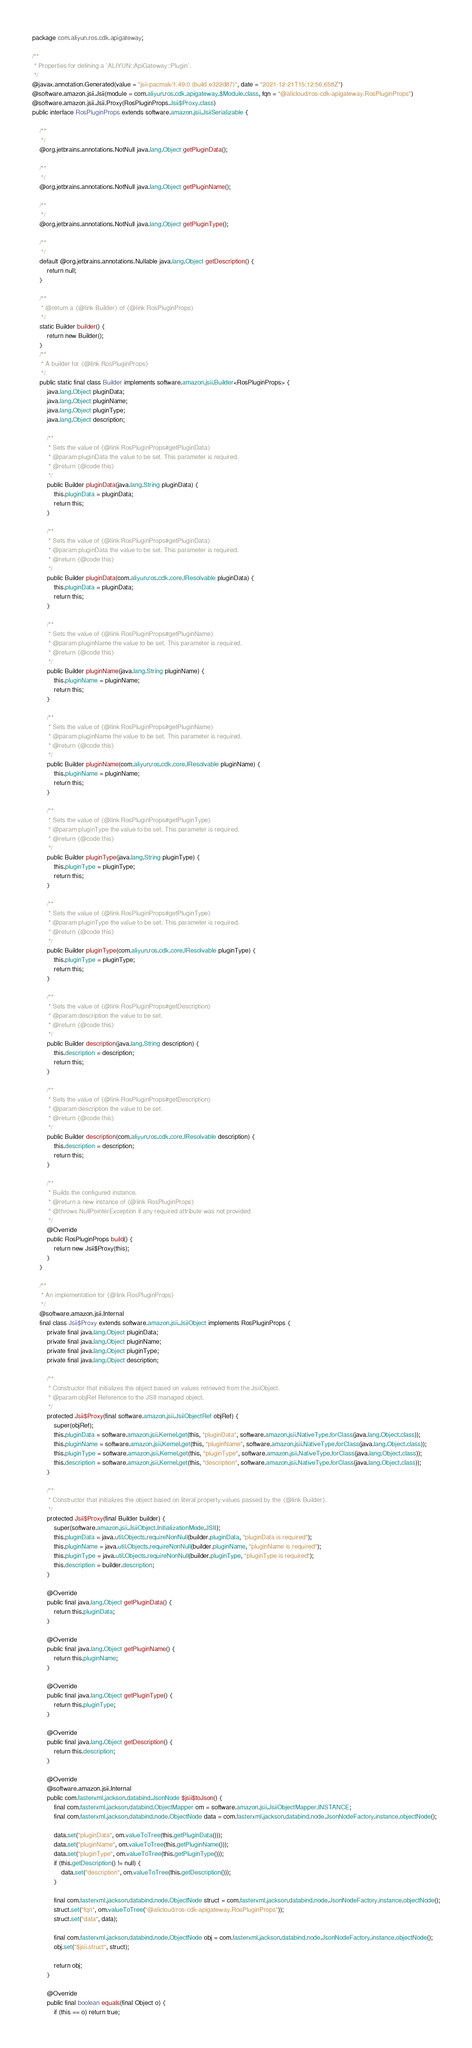<code> <loc_0><loc_0><loc_500><loc_500><_Java_>package com.aliyun.ros.cdk.apigateway;

/**
 * Properties for defining a `ALIYUN::ApiGateway::Plugin`.
 */
@javax.annotation.Generated(value = "jsii-pacmak/1.49.0 (build e322d87)", date = "2021-12-21T15:12:56.658Z")
@software.amazon.jsii.Jsii(module = com.aliyun.ros.cdk.apigateway.$Module.class, fqn = "@alicloud/ros-cdk-apigateway.RosPluginProps")
@software.amazon.jsii.Jsii.Proxy(RosPluginProps.Jsii$Proxy.class)
public interface RosPluginProps extends software.amazon.jsii.JsiiSerializable {

    /**
     */
    @org.jetbrains.annotations.NotNull java.lang.Object getPluginData();

    /**
     */
    @org.jetbrains.annotations.NotNull java.lang.Object getPluginName();

    /**
     */
    @org.jetbrains.annotations.NotNull java.lang.Object getPluginType();

    /**
     */
    default @org.jetbrains.annotations.Nullable java.lang.Object getDescription() {
        return null;
    }

    /**
     * @return a {@link Builder} of {@link RosPluginProps}
     */
    static Builder builder() {
        return new Builder();
    }
    /**
     * A builder for {@link RosPluginProps}
     */
    public static final class Builder implements software.amazon.jsii.Builder<RosPluginProps> {
        java.lang.Object pluginData;
        java.lang.Object pluginName;
        java.lang.Object pluginType;
        java.lang.Object description;

        /**
         * Sets the value of {@link RosPluginProps#getPluginData}
         * @param pluginData the value to be set. This parameter is required.
         * @return {@code this}
         */
        public Builder pluginData(java.lang.String pluginData) {
            this.pluginData = pluginData;
            return this;
        }

        /**
         * Sets the value of {@link RosPluginProps#getPluginData}
         * @param pluginData the value to be set. This parameter is required.
         * @return {@code this}
         */
        public Builder pluginData(com.aliyun.ros.cdk.core.IResolvable pluginData) {
            this.pluginData = pluginData;
            return this;
        }

        /**
         * Sets the value of {@link RosPluginProps#getPluginName}
         * @param pluginName the value to be set. This parameter is required.
         * @return {@code this}
         */
        public Builder pluginName(java.lang.String pluginName) {
            this.pluginName = pluginName;
            return this;
        }

        /**
         * Sets the value of {@link RosPluginProps#getPluginName}
         * @param pluginName the value to be set. This parameter is required.
         * @return {@code this}
         */
        public Builder pluginName(com.aliyun.ros.cdk.core.IResolvable pluginName) {
            this.pluginName = pluginName;
            return this;
        }

        /**
         * Sets the value of {@link RosPluginProps#getPluginType}
         * @param pluginType the value to be set. This parameter is required.
         * @return {@code this}
         */
        public Builder pluginType(java.lang.String pluginType) {
            this.pluginType = pluginType;
            return this;
        }

        /**
         * Sets the value of {@link RosPluginProps#getPluginType}
         * @param pluginType the value to be set. This parameter is required.
         * @return {@code this}
         */
        public Builder pluginType(com.aliyun.ros.cdk.core.IResolvable pluginType) {
            this.pluginType = pluginType;
            return this;
        }

        /**
         * Sets the value of {@link RosPluginProps#getDescription}
         * @param description the value to be set.
         * @return {@code this}
         */
        public Builder description(java.lang.String description) {
            this.description = description;
            return this;
        }

        /**
         * Sets the value of {@link RosPluginProps#getDescription}
         * @param description the value to be set.
         * @return {@code this}
         */
        public Builder description(com.aliyun.ros.cdk.core.IResolvable description) {
            this.description = description;
            return this;
        }

        /**
         * Builds the configured instance.
         * @return a new instance of {@link RosPluginProps}
         * @throws NullPointerException if any required attribute was not provided
         */
        @Override
        public RosPluginProps build() {
            return new Jsii$Proxy(this);
        }
    }

    /**
     * An implementation for {@link RosPluginProps}
     */
    @software.amazon.jsii.Internal
    final class Jsii$Proxy extends software.amazon.jsii.JsiiObject implements RosPluginProps {
        private final java.lang.Object pluginData;
        private final java.lang.Object pluginName;
        private final java.lang.Object pluginType;
        private final java.lang.Object description;

        /**
         * Constructor that initializes the object based on values retrieved from the JsiiObject.
         * @param objRef Reference to the JSII managed object.
         */
        protected Jsii$Proxy(final software.amazon.jsii.JsiiObjectRef objRef) {
            super(objRef);
            this.pluginData = software.amazon.jsii.Kernel.get(this, "pluginData", software.amazon.jsii.NativeType.forClass(java.lang.Object.class));
            this.pluginName = software.amazon.jsii.Kernel.get(this, "pluginName", software.amazon.jsii.NativeType.forClass(java.lang.Object.class));
            this.pluginType = software.amazon.jsii.Kernel.get(this, "pluginType", software.amazon.jsii.NativeType.forClass(java.lang.Object.class));
            this.description = software.amazon.jsii.Kernel.get(this, "description", software.amazon.jsii.NativeType.forClass(java.lang.Object.class));
        }

        /**
         * Constructor that initializes the object based on literal property values passed by the {@link Builder}.
         */
        protected Jsii$Proxy(final Builder builder) {
            super(software.amazon.jsii.JsiiObject.InitializationMode.JSII);
            this.pluginData = java.util.Objects.requireNonNull(builder.pluginData, "pluginData is required");
            this.pluginName = java.util.Objects.requireNonNull(builder.pluginName, "pluginName is required");
            this.pluginType = java.util.Objects.requireNonNull(builder.pluginType, "pluginType is required");
            this.description = builder.description;
        }

        @Override
        public final java.lang.Object getPluginData() {
            return this.pluginData;
        }

        @Override
        public final java.lang.Object getPluginName() {
            return this.pluginName;
        }

        @Override
        public final java.lang.Object getPluginType() {
            return this.pluginType;
        }

        @Override
        public final java.lang.Object getDescription() {
            return this.description;
        }

        @Override
        @software.amazon.jsii.Internal
        public com.fasterxml.jackson.databind.JsonNode $jsii$toJson() {
            final com.fasterxml.jackson.databind.ObjectMapper om = software.amazon.jsii.JsiiObjectMapper.INSTANCE;
            final com.fasterxml.jackson.databind.node.ObjectNode data = com.fasterxml.jackson.databind.node.JsonNodeFactory.instance.objectNode();

            data.set("pluginData", om.valueToTree(this.getPluginData()));
            data.set("pluginName", om.valueToTree(this.getPluginName()));
            data.set("pluginType", om.valueToTree(this.getPluginType()));
            if (this.getDescription() != null) {
                data.set("description", om.valueToTree(this.getDescription()));
            }

            final com.fasterxml.jackson.databind.node.ObjectNode struct = com.fasterxml.jackson.databind.node.JsonNodeFactory.instance.objectNode();
            struct.set("fqn", om.valueToTree("@alicloud/ros-cdk-apigateway.RosPluginProps"));
            struct.set("data", data);

            final com.fasterxml.jackson.databind.node.ObjectNode obj = com.fasterxml.jackson.databind.node.JsonNodeFactory.instance.objectNode();
            obj.set("$jsii.struct", struct);

            return obj;
        }

        @Override
        public final boolean equals(final Object o) {
            if (this == o) return true;</code> 